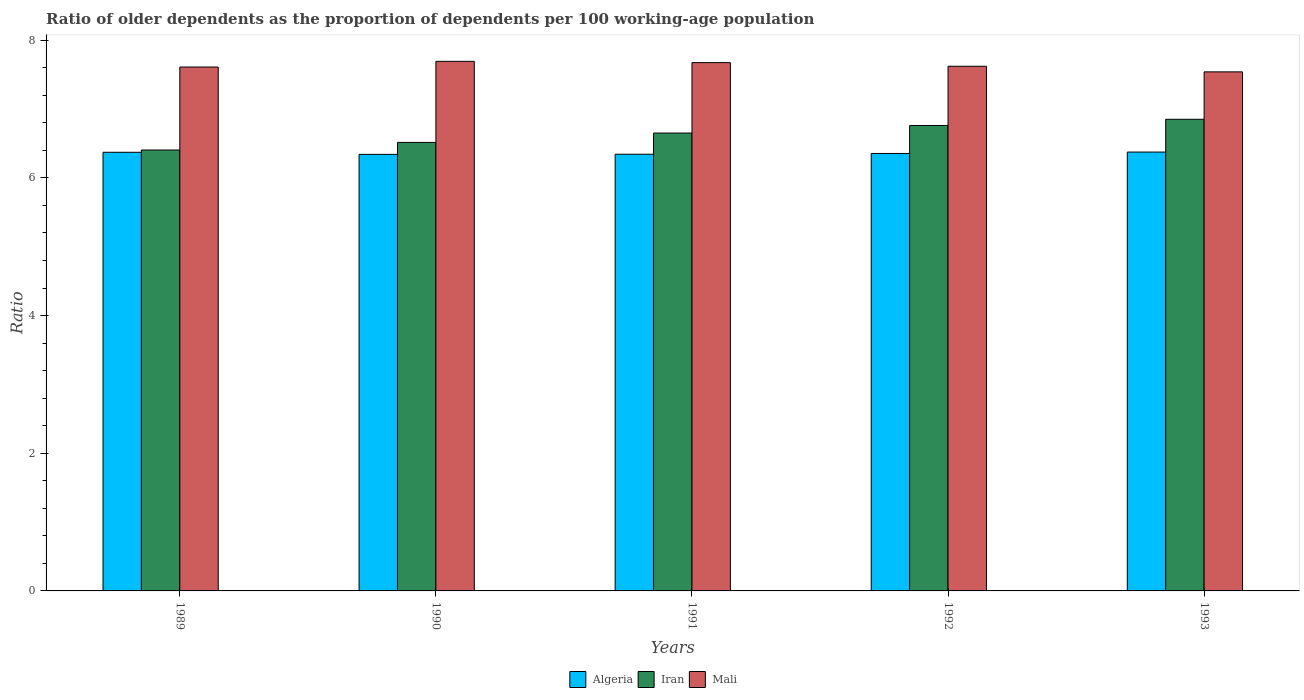Are the number of bars per tick equal to the number of legend labels?
Make the answer very short. Yes. Are the number of bars on each tick of the X-axis equal?
Ensure brevity in your answer.  Yes. How many bars are there on the 5th tick from the left?
Your answer should be compact. 3. How many bars are there on the 5th tick from the right?
Keep it short and to the point. 3. In how many cases, is the number of bars for a given year not equal to the number of legend labels?
Provide a short and direct response. 0. What is the age dependency ratio(old) in Algeria in 1993?
Give a very brief answer. 6.37. Across all years, what is the maximum age dependency ratio(old) in Iran?
Your response must be concise. 6.85. Across all years, what is the minimum age dependency ratio(old) in Iran?
Ensure brevity in your answer.  6.4. In which year was the age dependency ratio(old) in Mali minimum?
Keep it short and to the point. 1993. What is the total age dependency ratio(old) in Mali in the graph?
Your answer should be compact. 38.14. What is the difference between the age dependency ratio(old) in Mali in 1989 and that in 1993?
Your response must be concise. 0.07. What is the difference between the age dependency ratio(old) in Algeria in 1989 and the age dependency ratio(old) in Mali in 1991?
Provide a succinct answer. -1.3. What is the average age dependency ratio(old) in Mali per year?
Provide a short and direct response. 7.63. In the year 1989, what is the difference between the age dependency ratio(old) in Algeria and age dependency ratio(old) in Iran?
Offer a very short reply. -0.03. What is the ratio of the age dependency ratio(old) in Mali in 1992 to that in 1993?
Ensure brevity in your answer.  1.01. Is the difference between the age dependency ratio(old) in Algeria in 1991 and 1992 greater than the difference between the age dependency ratio(old) in Iran in 1991 and 1992?
Your response must be concise. Yes. What is the difference between the highest and the second highest age dependency ratio(old) in Mali?
Provide a short and direct response. 0.02. What is the difference between the highest and the lowest age dependency ratio(old) in Mali?
Offer a very short reply. 0.15. Is the sum of the age dependency ratio(old) in Mali in 1989 and 1992 greater than the maximum age dependency ratio(old) in Algeria across all years?
Your answer should be compact. Yes. What does the 2nd bar from the left in 1991 represents?
Provide a succinct answer. Iran. What does the 1st bar from the right in 1990 represents?
Offer a terse response. Mali. How many bars are there?
Your answer should be compact. 15. Are all the bars in the graph horizontal?
Ensure brevity in your answer.  No. How many years are there in the graph?
Your answer should be compact. 5. What is the difference between two consecutive major ticks on the Y-axis?
Keep it short and to the point. 2. Does the graph contain any zero values?
Your answer should be compact. No. Does the graph contain grids?
Give a very brief answer. No. Where does the legend appear in the graph?
Keep it short and to the point. Bottom center. What is the title of the graph?
Provide a short and direct response. Ratio of older dependents as the proportion of dependents per 100 working-age population. Does "Qatar" appear as one of the legend labels in the graph?
Your response must be concise. No. What is the label or title of the X-axis?
Offer a very short reply. Years. What is the label or title of the Y-axis?
Make the answer very short. Ratio. What is the Ratio in Algeria in 1989?
Your answer should be very brief. 6.37. What is the Ratio in Iran in 1989?
Ensure brevity in your answer.  6.4. What is the Ratio of Mali in 1989?
Keep it short and to the point. 7.61. What is the Ratio of Algeria in 1990?
Offer a very short reply. 6.34. What is the Ratio of Iran in 1990?
Make the answer very short. 6.51. What is the Ratio in Mali in 1990?
Ensure brevity in your answer.  7.69. What is the Ratio of Algeria in 1991?
Keep it short and to the point. 6.34. What is the Ratio of Iran in 1991?
Offer a very short reply. 6.65. What is the Ratio of Mali in 1991?
Ensure brevity in your answer.  7.67. What is the Ratio in Algeria in 1992?
Your answer should be very brief. 6.35. What is the Ratio of Iran in 1992?
Provide a short and direct response. 6.76. What is the Ratio in Mali in 1992?
Ensure brevity in your answer.  7.62. What is the Ratio in Algeria in 1993?
Keep it short and to the point. 6.37. What is the Ratio of Iran in 1993?
Ensure brevity in your answer.  6.85. What is the Ratio in Mali in 1993?
Your answer should be compact. 7.54. Across all years, what is the maximum Ratio in Algeria?
Your answer should be very brief. 6.37. Across all years, what is the maximum Ratio of Iran?
Give a very brief answer. 6.85. Across all years, what is the maximum Ratio in Mali?
Offer a very short reply. 7.69. Across all years, what is the minimum Ratio in Algeria?
Ensure brevity in your answer.  6.34. Across all years, what is the minimum Ratio in Iran?
Make the answer very short. 6.4. Across all years, what is the minimum Ratio of Mali?
Offer a very short reply. 7.54. What is the total Ratio of Algeria in the graph?
Make the answer very short. 31.79. What is the total Ratio of Iran in the graph?
Provide a short and direct response. 33.18. What is the total Ratio of Mali in the graph?
Provide a short and direct response. 38.14. What is the difference between the Ratio of Algeria in 1989 and that in 1990?
Give a very brief answer. 0.03. What is the difference between the Ratio of Iran in 1989 and that in 1990?
Provide a succinct answer. -0.11. What is the difference between the Ratio of Mali in 1989 and that in 1990?
Offer a very short reply. -0.08. What is the difference between the Ratio of Algeria in 1989 and that in 1991?
Provide a succinct answer. 0.03. What is the difference between the Ratio in Iran in 1989 and that in 1991?
Offer a very short reply. -0.25. What is the difference between the Ratio in Mali in 1989 and that in 1991?
Make the answer very short. -0.06. What is the difference between the Ratio of Algeria in 1989 and that in 1992?
Give a very brief answer. 0.02. What is the difference between the Ratio in Iran in 1989 and that in 1992?
Provide a succinct answer. -0.36. What is the difference between the Ratio in Mali in 1989 and that in 1992?
Provide a succinct answer. -0.01. What is the difference between the Ratio in Algeria in 1989 and that in 1993?
Offer a very short reply. -0. What is the difference between the Ratio of Iran in 1989 and that in 1993?
Make the answer very short. -0.45. What is the difference between the Ratio of Mali in 1989 and that in 1993?
Make the answer very short. 0.07. What is the difference between the Ratio in Algeria in 1990 and that in 1991?
Your response must be concise. -0. What is the difference between the Ratio in Iran in 1990 and that in 1991?
Make the answer very short. -0.14. What is the difference between the Ratio of Mali in 1990 and that in 1991?
Give a very brief answer. 0.02. What is the difference between the Ratio of Algeria in 1990 and that in 1992?
Provide a short and direct response. -0.01. What is the difference between the Ratio in Iran in 1990 and that in 1992?
Ensure brevity in your answer.  -0.25. What is the difference between the Ratio of Mali in 1990 and that in 1992?
Your response must be concise. 0.07. What is the difference between the Ratio in Algeria in 1990 and that in 1993?
Give a very brief answer. -0.03. What is the difference between the Ratio of Iran in 1990 and that in 1993?
Give a very brief answer. -0.34. What is the difference between the Ratio in Mali in 1990 and that in 1993?
Offer a terse response. 0.15. What is the difference between the Ratio of Algeria in 1991 and that in 1992?
Provide a short and direct response. -0.01. What is the difference between the Ratio of Iran in 1991 and that in 1992?
Provide a succinct answer. -0.11. What is the difference between the Ratio in Mali in 1991 and that in 1992?
Give a very brief answer. 0.05. What is the difference between the Ratio of Algeria in 1991 and that in 1993?
Offer a very short reply. -0.03. What is the difference between the Ratio of Mali in 1991 and that in 1993?
Make the answer very short. 0.13. What is the difference between the Ratio of Algeria in 1992 and that in 1993?
Provide a short and direct response. -0.02. What is the difference between the Ratio in Iran in 1992 and that in 1993?
Give a very brief answer. -0.09. What is the difference between the Ratio in Mali in 1992 and that in 1993?
Ensure brevity in your answer.  0.08. What is the difference between the Ratio in Algeria in 1989 and the Ratio in Iran in 1990?
Give a very brief answer. -0.14. What is the difference between the Ratio in Algeria in 1989 and the Ratio in Mali in 1990?
Keep it short and to the point. -1.32. What is the difference between the Ratio of Iran in 1989 and the Ratio of Mali in 1990?
Offer a very short reply. -1.29. What is the difference between the Ratio of Algeria in 1989 and the Ratio of Iran in 1991?
Keep it short and to the point. -0.28. What is the difference between the Ratio in Algeria in 1989 and the Ratio in Mali in 1991?
Give a very brief answer. -1.3. What is the difference between the Ratio in Iran in 1989 and the Ratio in Mali in 1991?
Provide a succinct answer. -1.27. What is the difference between the Ratio in Algeria in 1989 and the Ratio in Iran in 1992?
Provide a short and direct response. -0.39. What is the difference between the Ratio in Algeria in 1989 and the Ratio in Mali in 1992?
Make the answer very short. -1.25. What is the difference between the Ratio in Iran in 1989 and the Ratio in Mali in 1992?
Offer a very short reply. -1.22. What is the difference between the Ratio in Algeria in 1989 and the Ratio in Iran in 1993?
Provide a short and direct response. -0.48. What is the difference between the Ratio of Algeria in 1989 and the Ratio of Mali in 1993?
Give a very brief answer. -1.17. What is the difference between the Ratio in Iran in 1989 and the Ratio in Mali in 1993?
Your response must be concise. -1.14. What is the difference between the Ratio in Algeria in 1990 and the Ratio in Iran in 1991?
Provide a succinct answer. -0.31. What is the difference between the Ratio of Algeria in 1990 and the Ratio of Mali in 1991?
Ensure brevity in your answer.  -1.33. What is the difference between the Ratio in Iran in 1990 and the Ratio in Mali in 1991?
Ensure brevity in your answer.  -1.16. What is the difference between the Ratio of Algeria in 1990 and the Ratio of Iran in 1992?
Your answer should be very brief. -0.42. What is the difference between the Ratio in Algeria in 1990 and the Ratio in Mali in 1992?
Make the answer very short. -1.28. What is the difference between the Ratio of Iran in 1990 and the Ratio of Mali in 1992?
Give a very brief answer. -1.11. What is the difference between the Ratio of Algeria in 1990 and the Ratio of Iran in 1993?
Your response must be concise. -0.51. What is the difference between the Ratio of Algeria in 1990 and the Ratio of Mali in 1993?
Provide a succinct answer. -1.2. What is the difference between the Ratio of Iran in 1990 and the Ratio of Mali in 1993?
Provide a succinct answer. -1.02. What is the difference between the Ratio in Algeria in 1991 and the Ratio in Iran in 1992?
Give a very brief answer. -0.42. What is the difference between the Ratio of Algeria in 1991 and the Ratio of Mali in 1992?
Provide a short and direct response. -1.28. What is the difference between the Ratio in Iran in 1991 and the Ratio in Mali in 1992?
Ensure brevity in your answer.  -0.97. What is the difference between the Ratio in Algeria in 1991 and the Ratio in Iran in 1993?
Your answer should be very brief. -0.51. What is the difference between the Ratio of Algeria in 1991 and the Ratio of Mali in 1993?
Your answer should be very brief. -1.2. What is the difference between the Ratio in Iran in 1991 and the Ratio in Mali in 1993?
Keep it short and to the point. -0.89. What is the difference between the Ratio in Algeria in 1992 and the Ratio in Iran in 1993?
Your response must be concise. -0.5. What is the difference between the Ratio of Algeria in 1992 and the Ratio of Mali in 1993?
Offer a very short reply. -1.19. What is the difference between the Ratio in Iran in 1992 and the Ratio in Mali in 1993?
Make the answer very short. -0.78. What is the average Ratio in Algeria per year?
Offer a terse response. 6.36. What is the average Ratio of Iran per year?
Offer a very short reply. 6.64. What is the average Ratio of Mali per year?
Make the answer very short. 7.63. In the year 1989, what is the difference between the Ratio in Algeria and Ratio in Iran?
Your response must be concise. -0.03. In the year 1989, what is the difference between the Ratio of Algeria and Ratio of Mali?
Make the answer very short. -1.24. In the year 1989, what is the difference between the Ratio in Iran and Ratio in Mali?
Offer a terse response. -1.21. In the year 1990, what is the difference between the Ratio of Algeria and Ratio of Iran?
Your response must be concise. -0.17. In the year 1990, what is the difference between the Ratio of Algeria and Ratio of Mali?
Offer a terse response. -1.35. In the year 1990, what is the difference between the Ratio of Iran and Ratio of Mali?
Your response must be concise. -1.18. In the year 1991, what is the difference between the Ratio of Algeria and Ratio of Iran?
Your answer should be very brief. -0.31. In the year 1991, what is the difference between the Ratio in Algeria and Ratio in Mali?
Ensure brevity in your answer.  -1.33. In the year 1991, what is the difference between the Ratio of Iran and Ratio of Mali?
Provide a short and direct response. -1.02. In the year 1992, what is the difference between the Ratio in Algeria and Ratio in Iran?
Provide a succinct answer. -0.41. In the year 1992, what is the difference between the Ratio in Algeria and Ratio in Mali?
Provide a short and direct response. -1.27. In the year 1992, what is the difference between the Ratio in Iran and Ratio in Mali?
Make the answer very short. -0.86. In the year 1993, what is the difference between the Ratio in Algeria and Ratio in Iran?
Keep it short and to the point. -0.48. In the year 1993, what is the difference between the Ratio of Algeria and Ratio of Mali?
Offer a very short reply. -1.16. In the year 1993, what is the difference between the Ratio of Iran and Ratio of Mali?
Offer a very short reply. -0.69. What is the ratio of the Ratio of Iran in 1989 to that in 1990?
Your answer should be compact. 0.98. What is the ratio of the Ratio in Mali in 1989 to that in 1990?
Offer a terse response. 0.99. What is the ratio of the Ratio of Algeria in 1989 to that in 1991?
Your response must be concise. 1. What is the ratio of the Ratio in Iran in 1989 to that in 1991?
Offer a very short reply. 0.96. What is the ratio of the Ratio of Iran in 1989 to that in 1992?
Make the answer very short. 0.95. What is the ratio of the Ratio of Iran in 1989 to that in 1993?
Offer a very short reply. 0.93. What is the ratio of the Ratio in Mali in 1989 to that in 1993?
Give a very brief answer. 1.01. What is the ratio of the Ratio of Iran in 1990 to that in 1991?
Make the answer very short. 0.98. What is the ratio of the Ratio of Algeria in 1990 to that in 1992?
Provide a succinct answer. 1. What is the ratio of the Ratio in Iran in 1990 to that in 1992?
Provide a succinct answer. 0.96. What is the ratio of the Ratio of Mali in 1990 to that in 1992?
Offer a terse response. 1.01. What is the ratio of the Ratio in Iran in 1990 to that in 1993?
Keep it short and to the point. 0.95. What is the ratio of the Ratio in Mali in 1990 to that in 1993?
Give a very brief answer. 1.02. What is the ratio of the Ratio in Algeria in 1991 to that in 1992?
Provide a succinct answer. 1. What is the ratio of the Ratio of Iran in 1991 to that in 1992?
Your response must be concise. 0.98. What is the ratio of the Ratio in Mali in 1991 to that in 1992?
Provide a short and direct response. 1.01. What is the ratio of the Ratio in Algeria in 1991 to that in 1993?
Give a very brief answer. 0.99. What is the ratio of the Ratio of Iran in 1991 to that in 1993?
Keep it short and to the point. 0.97. What is the ratio of the Ratio in Mali in 1991 to that in 1993?
Your answer should be very brief. 1.02. What is the ratio of the Ratio of Iran in 1992 to that in 1993?
Your answer should be compact. 0.99. What is the ratio of the Ratio in Mali in 1992 to that in 1993?
Your answer should be very brief. 1.01. What is the difference between the highest and the second highest Ratio in Algeria?
Your answer should be very brief. 0. What is the difference between the highest and the second highest Ratio in Iran?
Ensure brevity in your answer.  0.09. What is the difference between the highest and the second highest Ratio in Mali?
Your answer should be compact. 0.02. What is the difference between the highest and the lowest Ratio in Algeria?
Offer a terse response. 0.03. What is the difference between the highest and the lowest Ratio in Iran?
Give a very brief answer. 0.45. What is the difference between the highest and the lowest Ratio of Mali?
Offer a terse response. 0.15. 